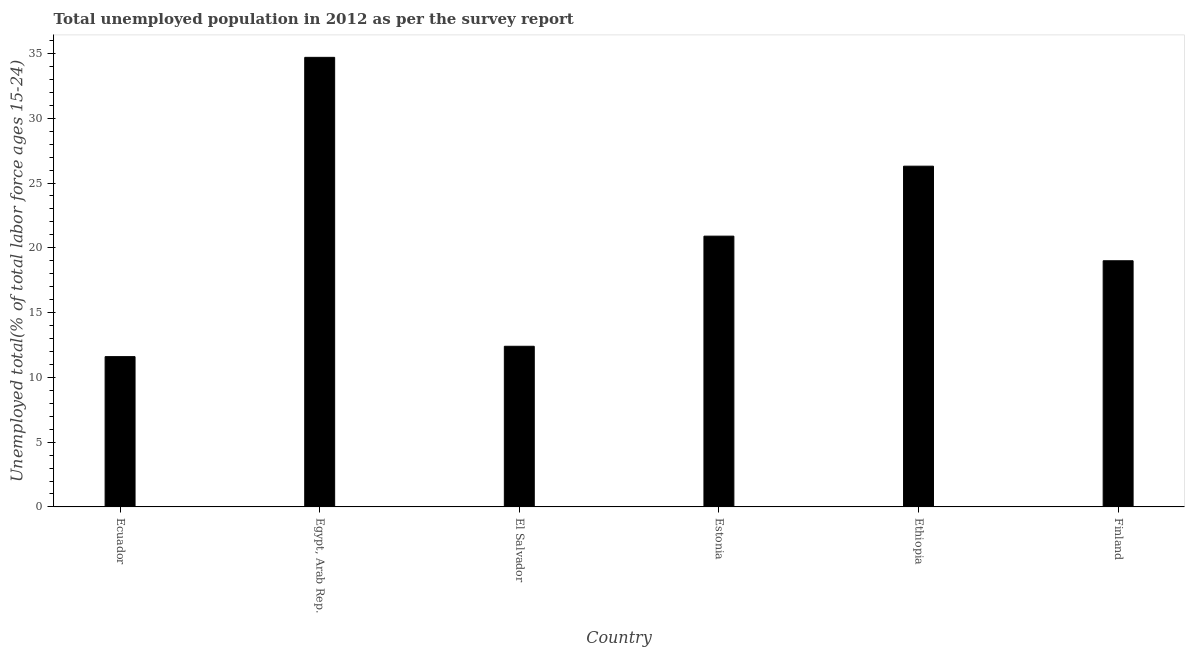What is the title of the graph?
Offer a very short reply. Total unemployed population in 2012 as per the survey report. What is the label or title of the Y-axis?
Provide a succinct answer. Unemployed total(% of total labor force ages 15-24). What is the unemployed youth in El Salvador?
Give a very brief answer. 12.4. Across all countries, what is the maximum unemployed youth?
Offer a very short reply. 34.7. Across all countries, what is the minimum unemployed youth?
Make the answer very short. 11.6. In which country was the unemployed youth maximum?
Offer a very short reply. Egypt, Arab Rep. In which country was the unemployed youth minimum?
Give a very brief answer. Ecuador. What is the sum of the unemployed youth?
Keep it short and to the point. 124.9. What is the average unemployed youth per country?
Give a very brief answer. 20.82. What is the median unemployed youth?
Your response must be concise. 19.95. In how many countries, is the unemployed youth greater than 10 %?
Offer a very short reply. 6. What is the ratio of the unemployed youth in Ecuador to that in El Salvador?
Offer a very short reply. 0.94. Is the difference between the unemployed youth in Estonia and Finland greater than the difference between any two countries?
Your response must be concise. No. Is the sum of the unemployed youth in Ecuador and Egypt, Arab Rep. greater than the maximum unemployed youth across all countries?
Your response must be concise. Yes. What is the difference between the highest and the lowest unemployed youth?
Your answer should be very brief. 23.1. In how many countries, is the unemployed youth greater than the average unemployed youth taken over all countries?
Your response must be concise. 3. How many bars are there?
Your answer should be compact. 6. Are all the bars in the graph horizontal?
Keep it short and to the point. No. How many countries are there in the graph?
Your response must be concise. 6. Are the values on the major ticks of Y-axis written in scientific E-notation?
Offer a terse response. No. What is the Unemployed total(% of total labor force ages 15-24) of Ecuador?
Your response must be concise. 11.6. What is the Unemployed total(% of total labor force ages 15-24) of Egypt, Arab Rep.?
Give a very brief answer. 34.7. What is the Unemployed total(% of total labor force ages 15-24) in El Salvador?
Offer a terse response. 12.4. What is the Unemployed total(% of total labor force ages 15-24) of Estonia?
Provide a short and direct response. 20.9. What is the Unemployed total(% of total labor force ages 15-24) of Ethiopia?
Ensure brevity in your answer.  26.3. What is the difference between the Unemployed total(% of total labor force ages 15-24) in Ecuador and Egypt, Arab Rep.?
Give a very brief answer. -23.1. What is the difference between the Unemployed total(% of total labor force ages 15-24) in Ecuador and El Salvador?
Your answer should be very brief. -0.8. What is the difference between the Unemployed total(% of total labor force ages 15-24) in Ecuador and Ethiopia?
Provide a succinct answer. -14.7. What is the difference between the Unemployed total(% of total labor force ages 15-24) in Egypt, Arab Rep. and El Salvador?
Your answer should be compact. 22.3. What is the difference between the Unemployed total(% of total labor force ages 15-24) in Egypt, Arab Rep. and Finland?
Your answer should be very brief. 15.7. What is the difference between the Unemployed total(% of total labor force ages 15-24) in Estonia and Ethiopia?
Offer a terse response. -5.4. What is the difference between the Unemployed total(% of total labor force ages 15-24) in Ethiopia and Finland?
Provide a short and direct response. 7.3. What is the ratio of the Unemployed total(% of total labor force ages 15-24) in Ecuador to that in Egypt, Arab Rep.?
Your answer should be compact. 0.33. What is the ratio of the Unemployed total(% of total labor force ages 15-24) in Ecuador to that in El Salvador?
Your answer should be very brief. 0.94. What is the ratio of the Unemployed total(% of total labor force ages 15-24) in Ecuador to that in Estonia?
Offer a terse response. 0.56. What is the ratio of the Unemployed total(% of total labor force ages 15-24) in Ecuador to that in Ethiopia?
Provide a short and direct response. 0.44. What is the ratio of the Unemployed total(% of total labor force ages 15-24) in Ecuador to that in Finland?
Offer a terse response. 0.61. What is the ratio of the Unemployed total(% of total labor force ages 15-24) in Egypt, Arab Rep. to that in El Salvador?
Give a very brief answer. 2.8. What is the ratio of the Unemployed total(% of total labor force ages 15-24) in Egypt, Arab Rep. to that in Estonia?
Provide a short and direct response. 1.66. What is the ratio of the Unemployed total(% of total labor force ages 15-24) in Egypt, Arab Rep. to that in Ethiopia?
Keep it short and to the point. 1.32. What is the ratio of the Unemployed total(% of total labor force ages 15-24) in Egypt, Arab Rep. to that in Finland?
Give a very brief answer. 1.83. What is the ratio of the Unemployed total(% of total labor force ages 15-24) in El Salvador to that in Estonia?
Your answer should be very brief. 0.59. What is the ratio of the Unemployed total(% of total labor force ages 15-24) in El Salvador to that in Ethiopia?
Your answer should be very brief. 0.47. What is the ratio of the Unemployed total(% of total labor force ages 15-24) in El Salvador to that in Finland?
Provide a short and direct response. 0.65. What is the ratio of the Unemployed total(% of total labor force ages 15-24) in Estonia to that in Ethiopia?
Keep it short and to the point. 0.8. What is the ratio of the Unemployed total(% of total labor force ages 15-24) in Ethiopia to that in Finland?
Ensure brevity in your answer.  1.38. 